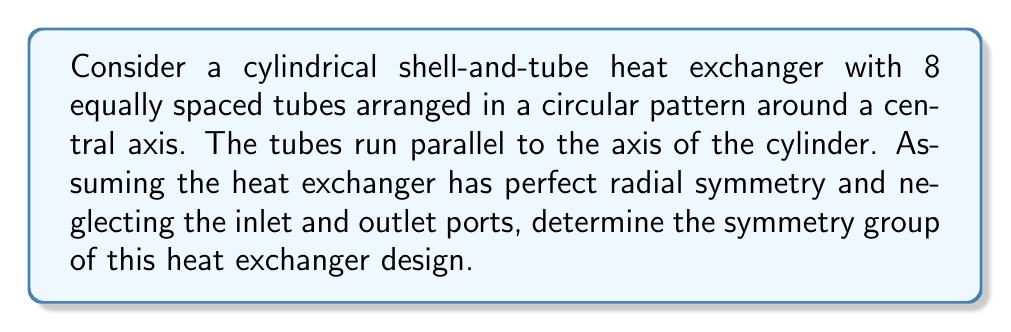Can you answer this question? To determine the symmetry group of this heat exchanger design, we need to consider its geometric properties and identify all symmetry operations that leave the design unchanged. Let's approach this step-by-step:

1. Rotational symmetry:
   The heat exchanger has 8 equally spaced tubes arranged in a circular pattern. This means it has 8-fold rotational symmetry about its central axis. The rotation angles are multiples of $\frac{2\pi}{8} = \frac{\pi}{4}$.

2. Reflection symmetry:
   With 8 tubes, there are 8 planes of reflection symmetry:
   - 4 planes passing through opposite tubes
   - 4 planes passing between adjacent tubes

3. Identifying the symmetry group:
   The combination of these symmetries (8 rotations and 8 reflections) forms the dihedral group $D_8$. 

4. Elements of $D_8$:
   - Identity: $e$
   - Rotations: $r, r^2, r^3, r^4, r^5, r^6, r^7$ (where $r$ is a rotation by $\frac{\pi}{4}$)
   - Reflections: $s, sr, sr^2, sr^3, sr^4, sr^5, sr^6, sr^7$ (where $s$ is a reflection)

5. Group properties:
   - Order of the group: $|D_8| = 16$
   - It is non-abelian, as rotations and reflections do not generally commute

6. Group presentation:
   $D_8 = \langle r,s \mid r^8 = s^2 = e, srs = r^{-1} \rangle$

This symmetry group fully describes all the ways in which the heat exchanger design remains unchanged under geometric transformations, assuming perfect radial symmetry and neglecting inlet/outlet ports.
Answer: $D_8$ 